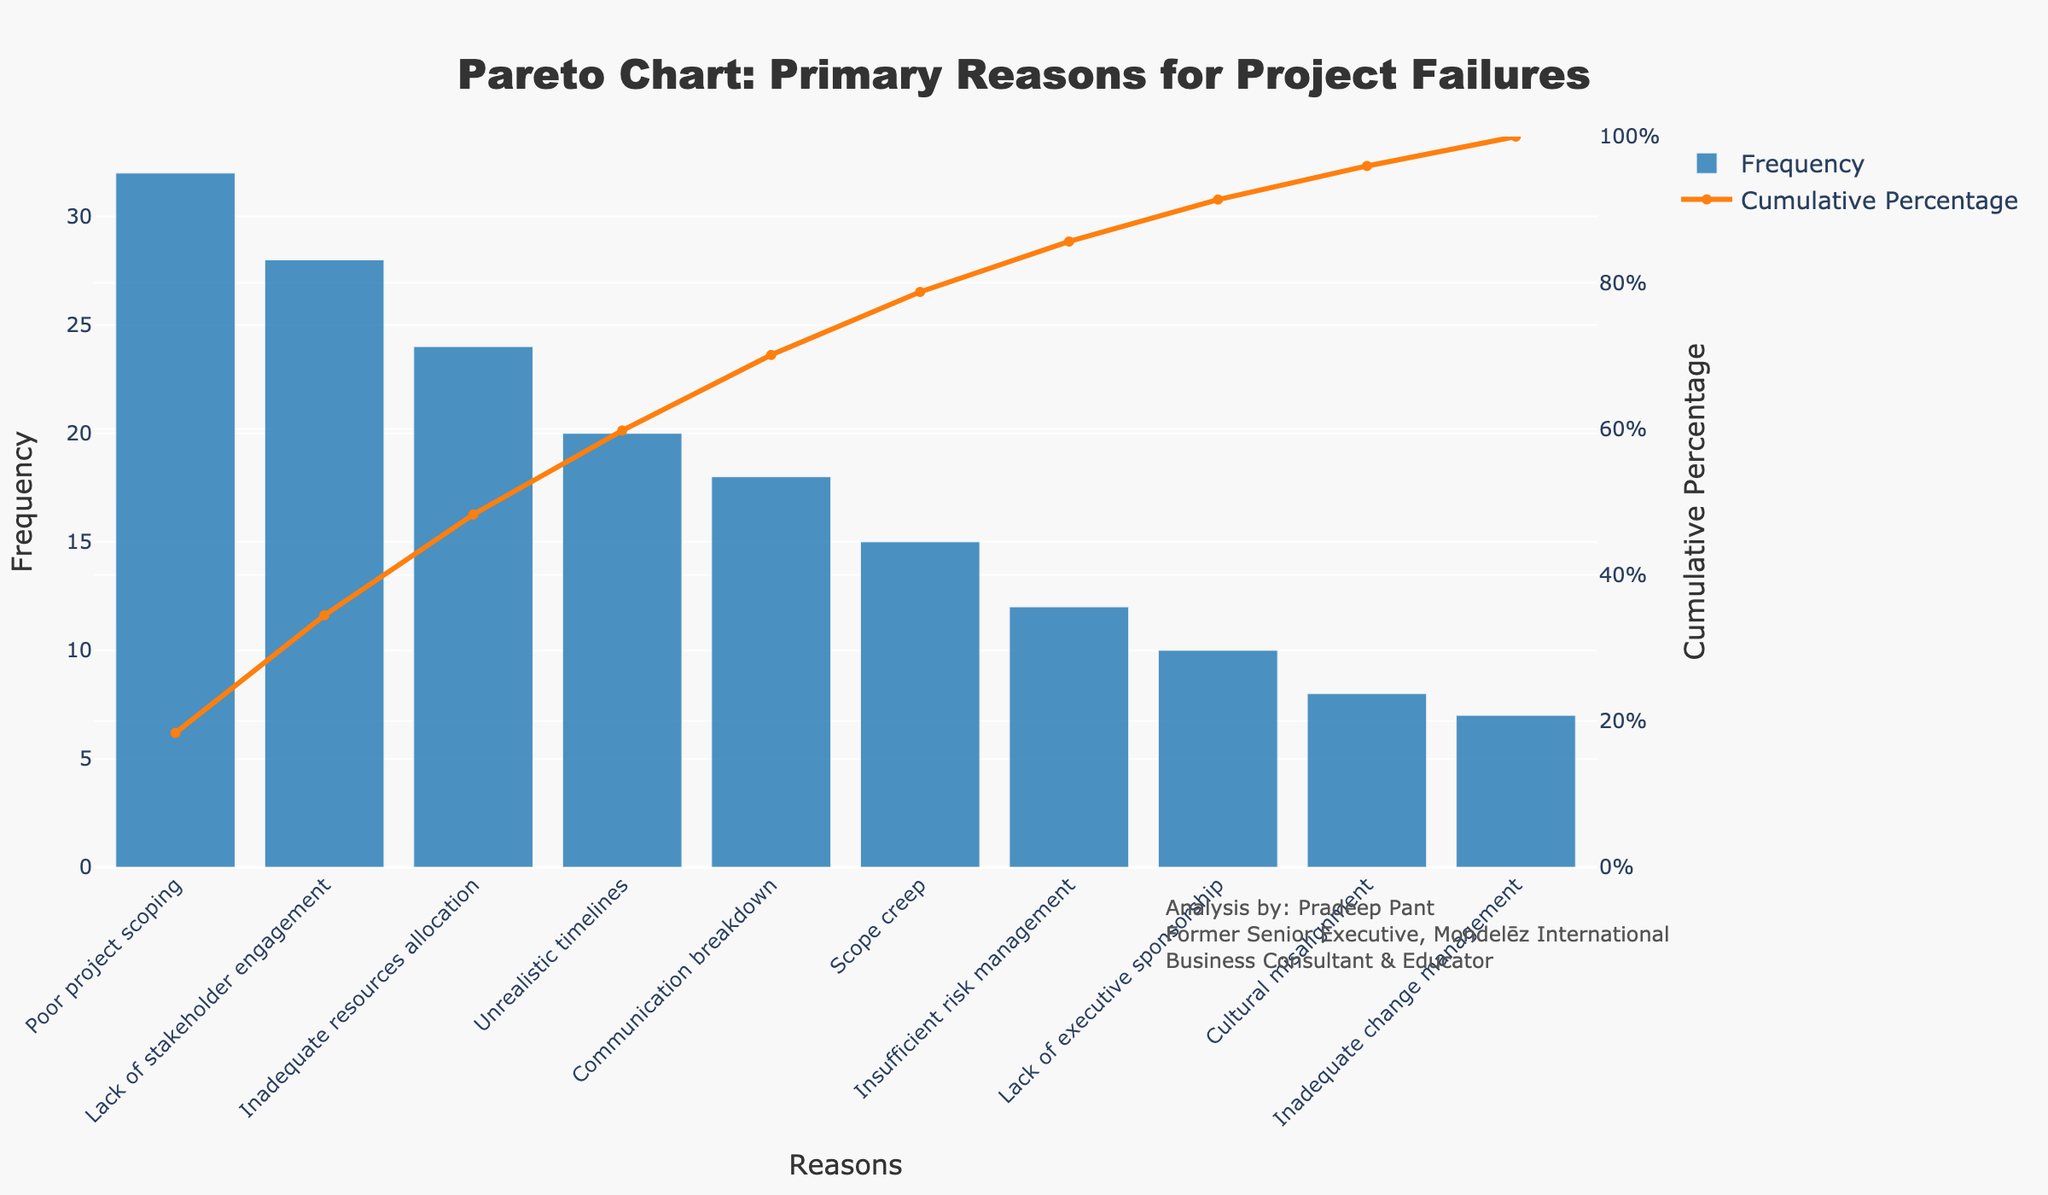What is the title of the figure? The title is located at the top of the figure. From the data provided in the code, the title of the Pareto chart is "Pareto Chart: Primary Reasons for Project Failures".
Answer: Pareto Chart: Primary Reasons for Project Failures Which reason for project failures has the highest frequency? The reason with the highest frequency is the first bar in the chart. Referring to the sorted data, "Poor project scoping" has the highest frequency of 32 occurrences.
Answer: Poor project scoping What is the cumulative percentage of the top three reasons for project failures? To find the cumulative percentage of the top three reasons, sum their frequencies and then divide by the total frequency, finally multiplying by 100. The top three reasons are "Poor project scoping" (32), "Lack of stakeholder engagement" (28), and "Inadequate resources allocation" (24). The sum is 32 + 28 + 24 = 84. The total frequency is 174. The cumulative percentage is (84/174) * 100 ≈ 48.28%.
Answer: 48.28% Which reason has a frequency of 18? The frequency value of 18 corresponds to one of the bars on the chart. From the provided data, "Communication breakdown" has a frequency of 18.
Answer: Communication breakdown How many reasons have a frequency greater than 20? Reasons with a frequency greater than 20 can be counted from the bars taller than the 20 marks in the figure. From the data, there are four reasons with such frequencies: "Poor project scoping" (32), "Lack of stakeholder engagement" (28), "Inadequate resources allocation" (24), and "Unrealistic timelines" (20).
Answer: 4 What percentage of project failures are due to "Scope creep" and "Insufficient risk management" combined? First, sum the frequencies of "Scope creep" and "Insufficient risk management" which are 15 and 12, respectively. The sum is 15 + 12 = 27. Next, divide by the total frequency (174) and multiply by 100 to obtain the percentage. The percentage is (27/174) * 100 ≈ 15.52%.
Answer: 15.52% Which is more frequent, "Cultural misalignment" or "Inadequate change management"? By comparing the frequencies from the bar heights in the chart, "Cultural misalignment" has a frequency of 8, while "Inadequate change management" has a frequency of 7. Therefore, "Cultural misalignment" is more frequent.
Answer: Cultural misalignment At what point does the cumulative percentage exceed 60%? To determine this, look at the cumulative percentage line on the figure. From the data, the "Unrealistic timelines" is the fourth reason with a cumulative percentage of approximately 60.34%; "Communication breakdown", the fifth, brings it to 70.11%.
Answer: At "Communication breakdown" What is the cumulative percentage after including "Lack of executive sponsorship"? "Lack of executive sponsorship" is the eighth reason. By summing the cumulative percentages before it (Poor project scoping 18.39% + Lack of stakeholder engagement 33.91% + Inadequate resources allocation 47.13% + Unrealistic timelines 58.62% + Communication breakdown 69.54% + Scope creep 78.16% + Insufficient risk management 84.09%), and adding the percentage contribution of "Lack of executive sponsorship" (10/174 * 100 ≈ 5.75%), we get approximately 89.83%.
Answer: 89.83% What are the colors used for the bars and the line in the chart? The colors can be visually identified from the figure. The bars are colored blue and the line is colored orange.
Answer: Blue for bars and orange for line 